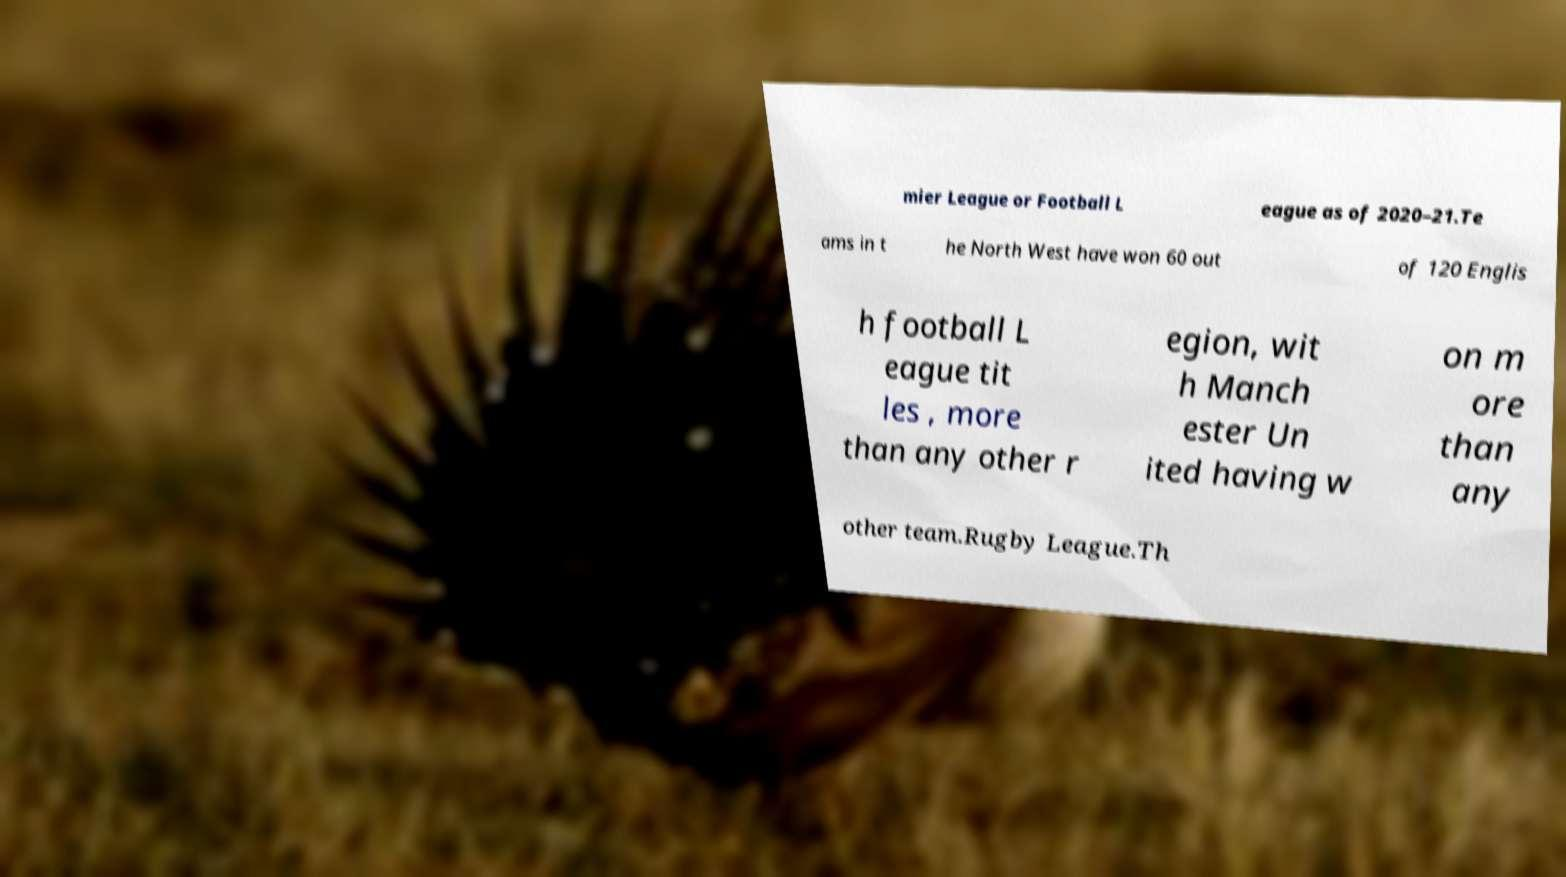Please read and relay the text visible in this image. What does it say? mier League or Football L eague as of 2020–21.Te ams in t he North West have won 60 out of 120 Englis h football L eague tit les , more than any other r egion, wit h Manch ester Un ited having w on m ore than any other team.Rugby League.Th 